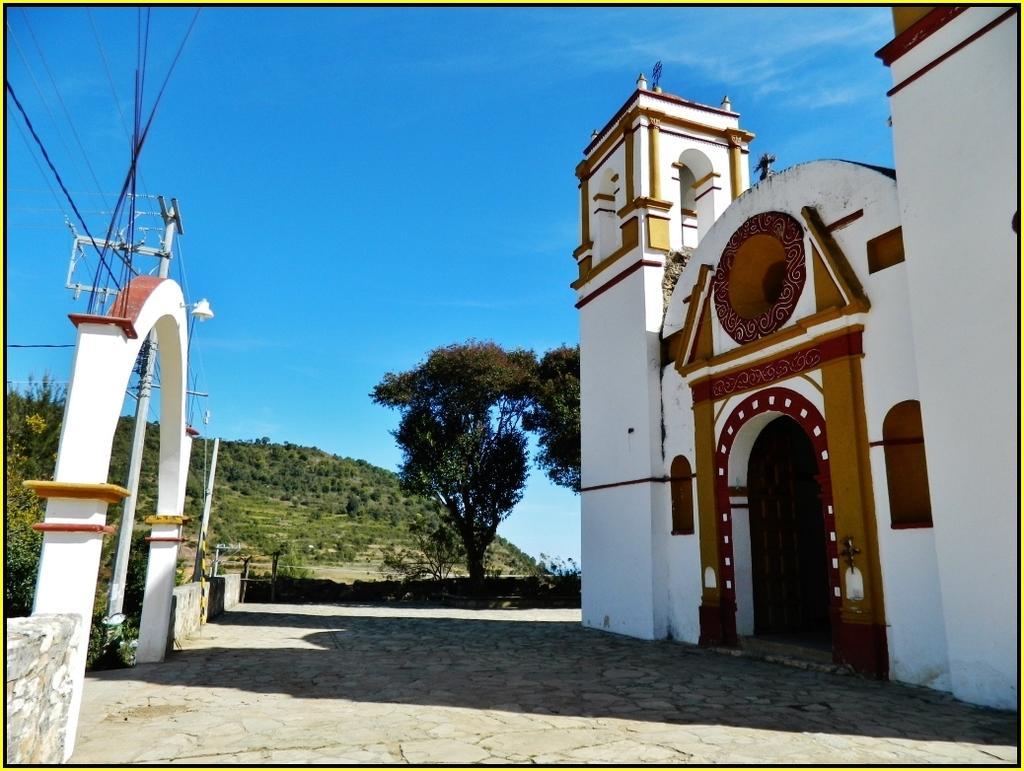Could you give a brief overview of what you see in this image? We can see building,arch,wires and poles. In the background we can see trees and sky in blue color. 